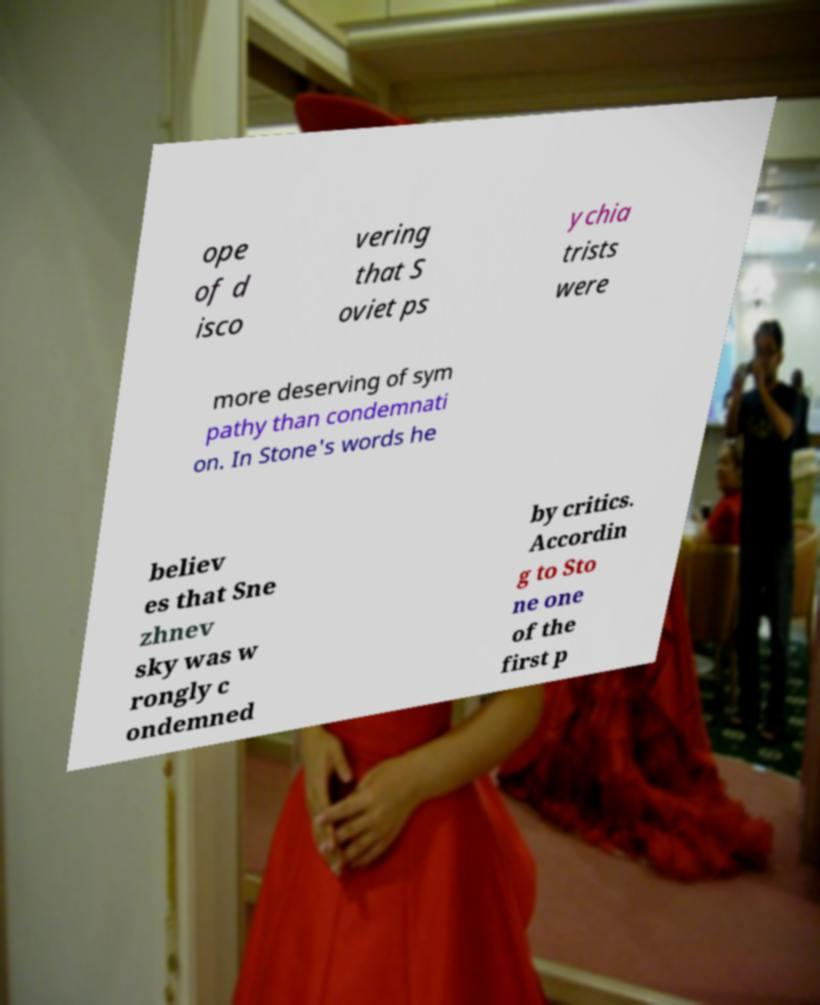Could you extract and type out the text from this image? ope of d isco vering that S oviet ps ychia trists were more deserving of sym pathy than condemnati on. In Stone's words he believ es that Sne zhnev sky was w rongly c ondemned by critics. Accordin g to Sto ne one of the first p 